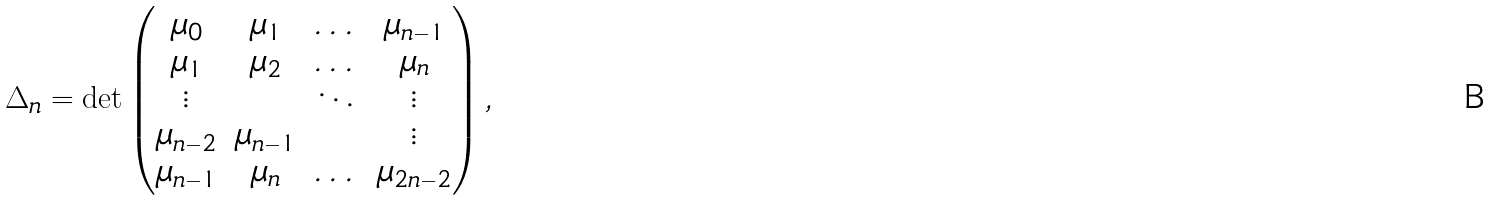Convert formula to latex. <formula><loc_0><loc_0><loc_500><loc_500>\Delta _ { n } = \det \begin{pmatrix} \mu _ { 0 } & \mu _ { 1 } & \dots & \mu _ { n - 1 } \\ \mu _ { 1 } & \mu _ { 2 } & \dots & \mu _ { n } \\ \vdots & & \ddots & \vdots \\ \mu _ { n - 2 } & \mu _ { n - 1 } & & \vdots \\ \mu _ { n - 1 } & \mu _ { n } & \dots & \mu _ { 2 n - 2 } \end{pmatrix} ,</formula> 